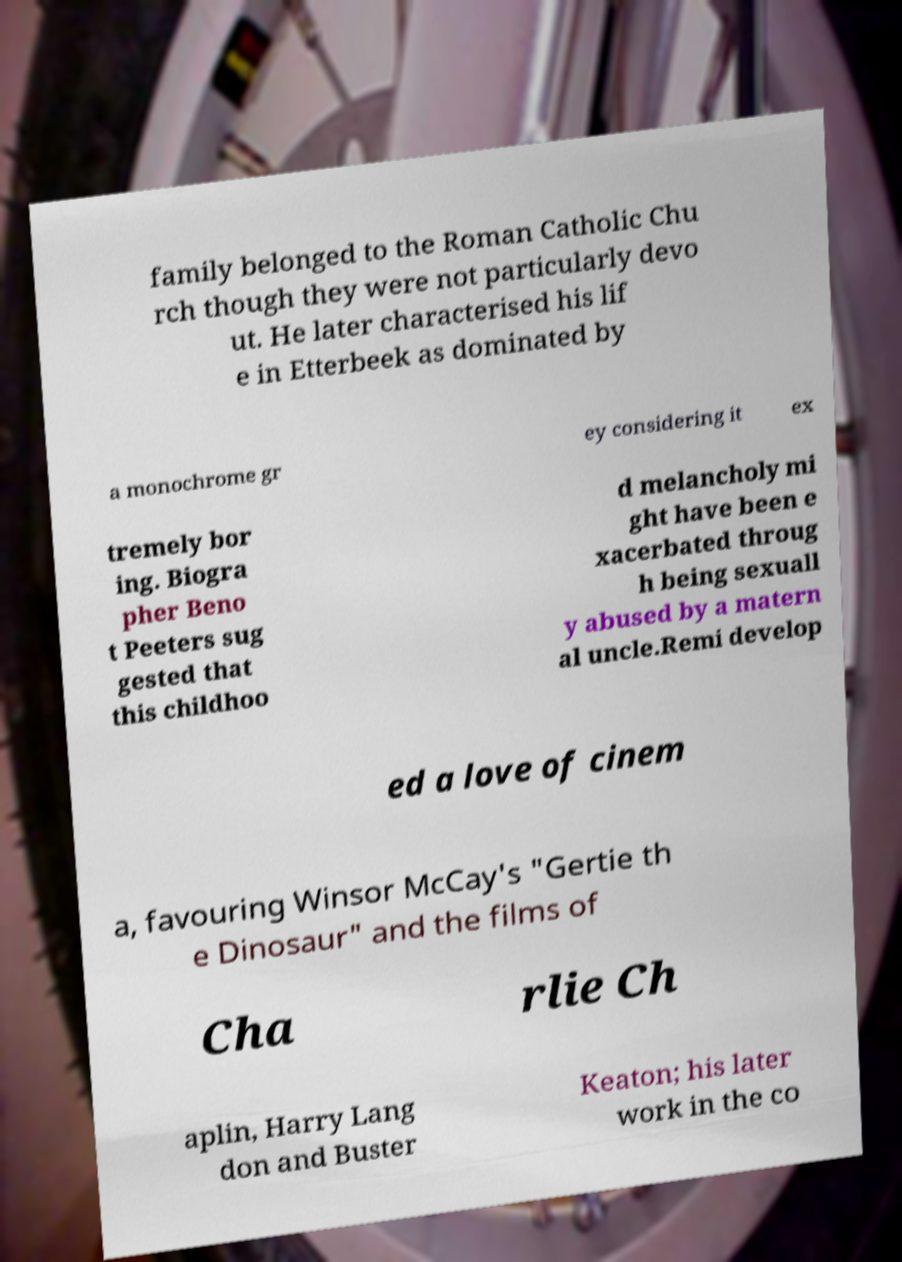I need the written content from this picture converted into text. Can you do that? family belonged to the Roman Catholic Chu rch though they were not particularly devo ut. He later characterised his lif e in Etterbeek as dominated by a monochrome gr ey considering it ex tremely bor ing. Biogra pher Beno t Peeters sug gested that this childhoo d melancholy mi ght have been e xacerbated throug h being sexuall y abused by a matern al uncle.Remi develop ed a love of cinem a, favouring Winsor McCay's "Gertie th e Dinosaur" and the films of Cha rlie Ch aplin, Harry Lang don and Buster Keaton; his later work in the co 